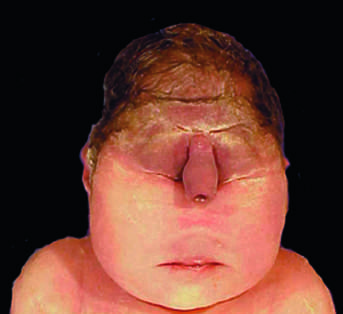what is this degree of external dysmorphogenesis associated with?
Answer the question using a single word or phrase. Severe internal anomalies 